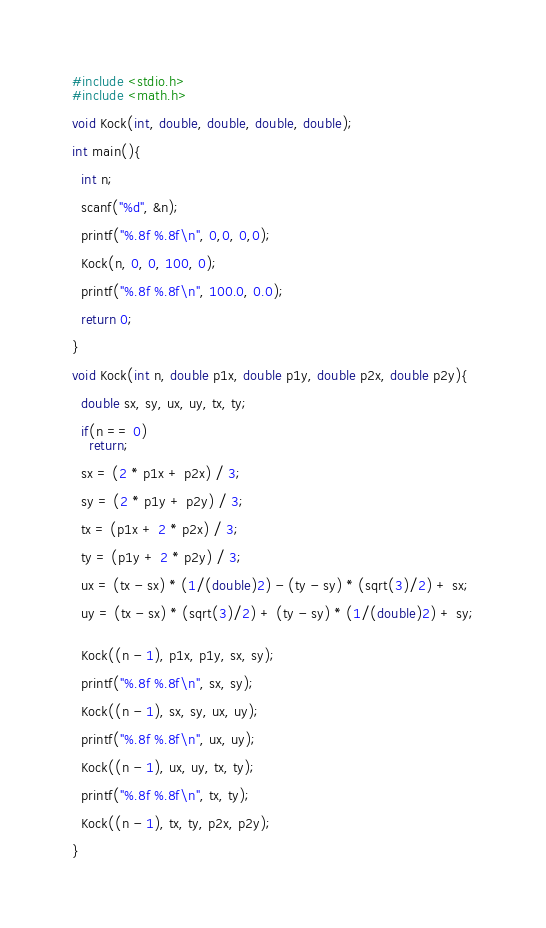<code> <loc_0><loc_0><loc_500><loc_500><_C_>#include <stdio.h>
#include <math.h>

void Kock(int, double, double, double, double);

int main(){

  int n;

  scanf("%d", &n);

  printf("%.8f %.8f\n", 0,0, 0,0);
  
  Kock(n, 0, 0, 100, 0);
 
  printf("%.8f %.8f\n", 100.0, 0.0);

  return 0;

}

void Kock(int n, double p1x, double p1y, double p2x, double p2y){
  
  double sx, sy, ux, uy, tx, ty;

  if(n == 0)
    return;

  sx = (2 * p1x + p2x) / 3;

  sy = (2 * p1y + p2y) / 3;

  tx = (p1x + 2 * p2x) / 3;

  ty = (p1y + 2 * p2y) / 3;

  ux = (tx - sx) * (1/(double)2) - (ty - sy) * (sqrt(3)/2) + sx;

  uy = (tx - sx) * (sqrt(3)/2) + (ty - sy) * (1/(double)2) + sy;
  

  Kock((n - 1), p1x, p1y, sx, sy);
  
  printf("%.8f %.8f\n", sx, sy);

  Kock((n - 1), sx, sy, ux, uy);

  printf("%.8f %.8f\n", ux, uy);

  Kock((n - 1), ux, uy, tx, ty);

  printf("%.8f %.8f\n", tx, ty);

  Kock((n - 1), tx, ty, p2x, p2y);
  
}</code> 